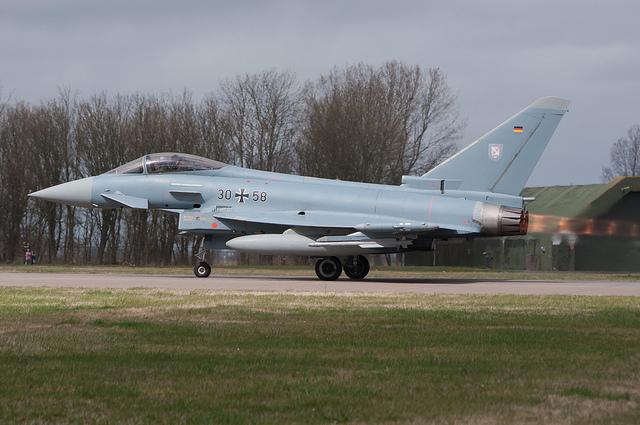Where do you see this type of vehicle?
Write a very short answer. Airport. What is the plane on?
Write a very short answer. Ground. What country is this jet fighter from?
Concise answer only. Germany. What military function is this built for?
Quick response, please. War. 